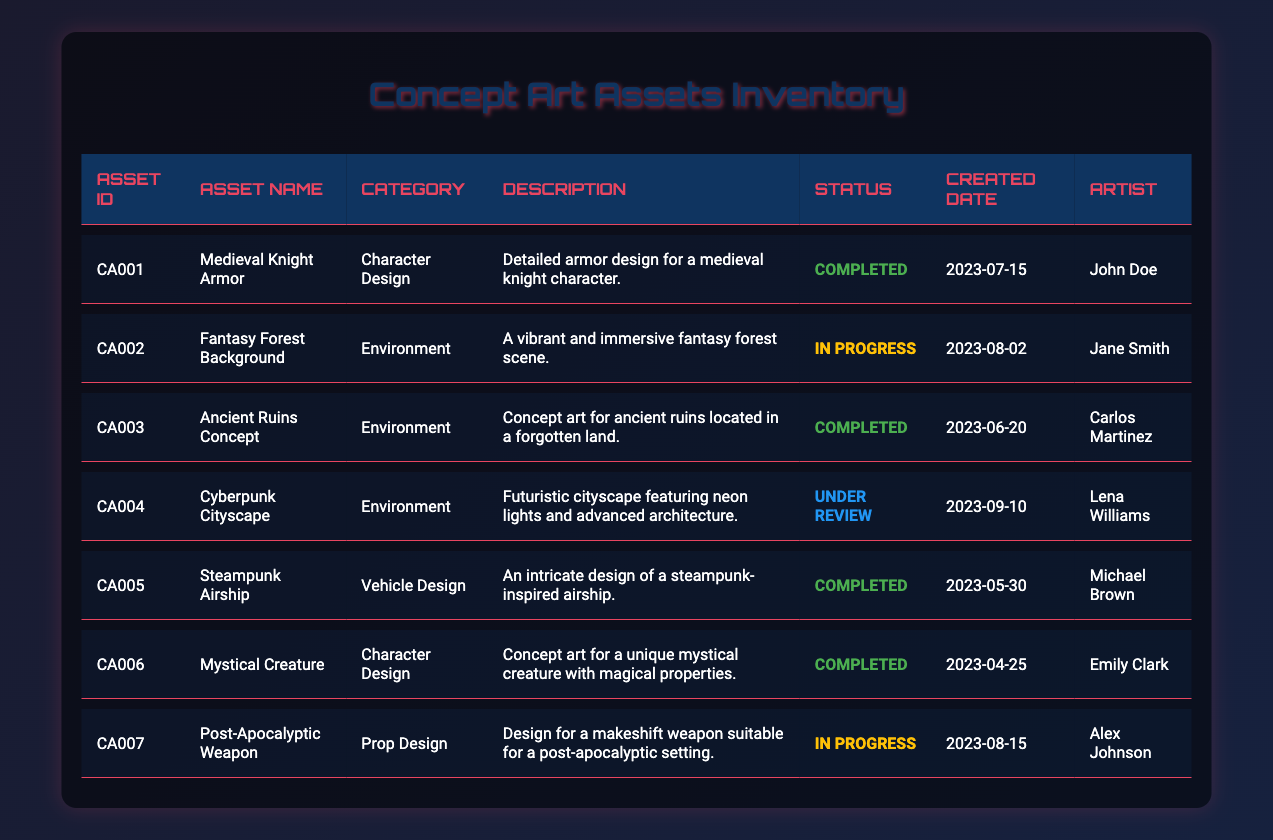What is the asset name of the item with asset ID CA003? The asset ID CA003 corresponds to the row for "Ancient Ruins Concept" in the table.
Answer: Ancient Ruins Concept How many assets are marked as "In Progress"? There are two assets listed under the status "In Progress": the "Fantasy Forest Background" and "Post-Apocalyptic Weapon". Counting these gives us a total of 2.
Answer: 2 Who is the artist of the "Cyberpunk Cityscape"? The row for "Cyberpunk Cityscape" reveals that Lena Williams is the artist for this asset.
Answer: Lena Williams Is there an asset that has been created before June 15, 2023, and is completed? Looking through the table, the "Mystical Creature" was created on April 25, 2023, and its status is "Completed", confirming that it meets these criteria.
Answer: Yes What is the most recent asset created, and what is its status? The most recent asset is "Cyberpunk Cityscape" created on September 10, 2023. Its status is "Under Review", as indicated in the corresponding row.
Answer: Under Review How many different categories are represented in the inventory? The table shows three distinct categories: "Character Design", "Environment", and "Vehicle Design", resulting in a total of 3 different categories.
Answer: 3 Which artist has contributed the most completed assets? By examining the statuses of the assets, both John Doe and Carlos Martinez have completed 1 asset each; however, Emily Clark completed 1 as well, while the rest are either in progress or under review, thus no artist has more than 1 completed asset.
Answer: Tied among three artists What category does the "Steampunk Airship" belong to? The row for "Steampunk Airship" indicates that it falls under the category of "Vehicle Design".
Answer: Vehicle Design What is the status of the "Post-Apocalyptic Weapon"? According to the table, the "Post-Apocalyptic Weapon" is listed as "In Progress".
Answer: In Progress 